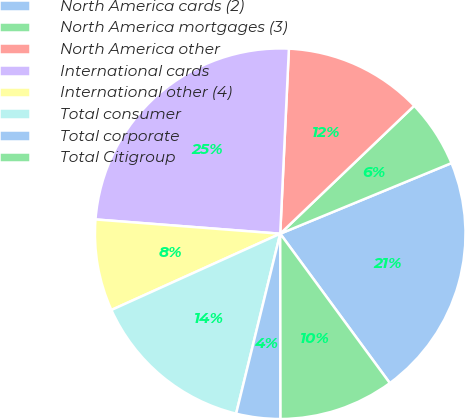Convert chart. <chart><loc_0><loc_0><loc_500><loc_500><pie_chart><fcel>North America cards (2)<fcel>North America mortgages (3)<fcel>North America other<fcel>International cards<fcel>International other (4)<fcel>Total consumer<fcel>Total corporate<fcel>Total Citigroup<nl><fcel>21.15%<fcel>5.91%<fcel>12.12%<fcel>24.52%<fcel>7.98%<fcel>14.42%<fcel>3.85%<fcel>10.05%<nl></chart> 